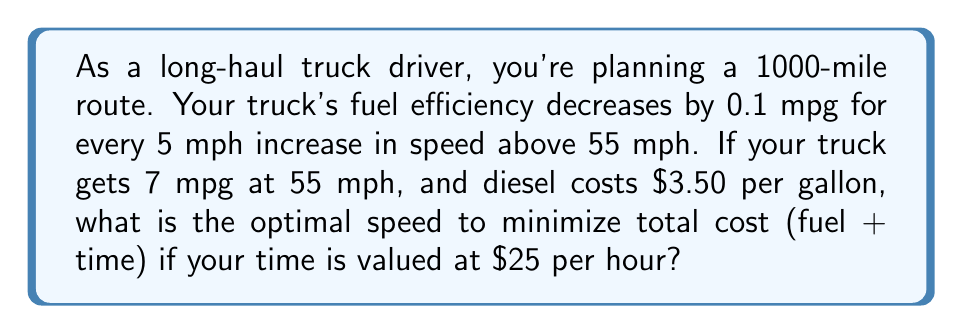Solve this math problem. Let's approach this step-by-step:

1) First, let's define our variables:
   $x$ = speed in mph
   $y$ = fuel efficiency in mpg
   $d$ = distance (1000 miles)
   $c$ = cost of diesel per gallon ($3.50)
   $t$ = value of time per hour ($25)

2) We can express fuel efficiency as a function of speed:
   $y = 7 - 0.02(x - 55)$ for $x \geq 55$

3) The total cost function will be the sum of fuel cost and time cost:
   $TC = \frac{dc}{y} + \frac{dt}{x}$

4) Substituting our fuel efficiency function:
   $TC = \frac{1000 \cdot 3.50}{7 - 0.02(x - 55)} + \frac{1000 \cdot 25}{x}$

5) To find the minimum, we differentiate TC with respect to x and set it to zero:
   $$\frac{dTC}{dx} = \frac{-70000 \cdot 3.50 \cdot (-0.02)}{(7 - 0.02(x - 55))^2} - \frac{1000 \cdot 25}{x^2} = 0$$

6) This equation is complex to solve analytically, so we can use numerical methods or graphing to find the solution.

7) Using a graphing calculator or software, we find that the minimum occurs at approximately $x = 61.8$ mph.

8) We can verify this by checking values around 61.8 mph:
   At 61 mph: TC = $636.07
   At 62 mph: TC = $635.99
   At 63 mph: TC = $636.02

Therefore, the optimal speed is approximately 62 mph.
Answer: The optimal speed to minimize total cost is approximately 62 mph. 